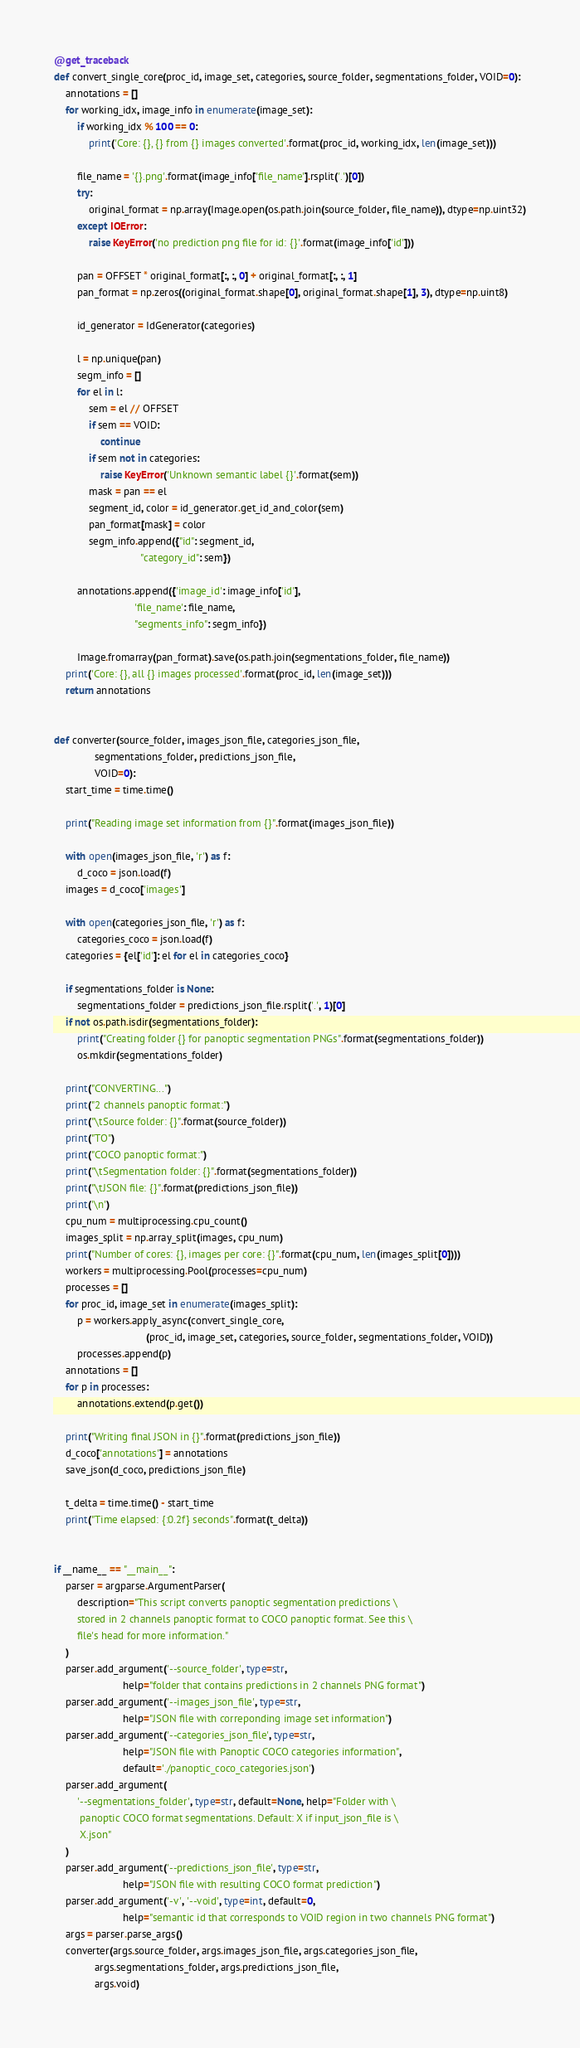<code> <loc_0><loc_0><loc_500><loc_500><_Python_>
@get_traceback
def convert_single_core(proc_id, image_set, categories, source_folder, segmentations_folder, VOID=0):
    annotations = []
    for working_idx, image_info in enumerate(image_set):
        if working_idx % 100 == 0:
            print('Core: {}, {} from {} images converted'.format(proc_id, working_idx, len(image_set)))

        file_name = '{}.png'.format(image_info['file_name'].rsplit('.')[0])
        try:
            original_format = np.array(Image.open(os.path.join(source_folder, file_name)), dtype=np.uint32)
        except IOError:
            raise KeyError('no prediction png file for id: {}'.format(image_info['id']))

        pan = OFFSET * original_format[:, :, 0] + original_format[:, :, 1]
        pan_format = np.zeros((original_format.shape[0], original_format.shape[1], 3), dtype=np.uint8)

        id_generator = IdGenerator(categories)

        l = np.unique(pan)
        segm_info = []
        for el in l:
            sem = el // OFFSET
            if sem == VOID:
                continue
            if sem not in categories:
                raise KeyError('Unknown semantic label {}'.format(sem))
            mask = pan == el
            segment_id, color = id_generator.get_id_and_color(sem)
            pan_format[mask] = color
            segm_info.append({"id": segment_id,
                              "category_id": sem})

        annotations.append({'image_id': image_info['id'],
                            'file_name': file_name,
                            "segments_info": segm_info})

        Image.fromarray(pan_format).save(os.path.join(segmentations_folder, file_name))
    print('Core: {}, all {} images processed'.format(proc_id, len(image_set)))
    return annotations


def converter(source_folder, images_json_file, categories_json_file,
              segmentations_folder, predictions_json_file,
              VOID=0):
    start_time = time.time()

    print("Reading image set information from {}".format(images_json_file))

    with open(images_json_file, 'r') as f:
        d_coco = json.load(f)
    images = d_coco['images']

    with open(categories_json_file, 'r') as f:
        categories_coco = json.load(f)
    categories = {el['id']: el for el in categories_coco}

    if segmentations_folder is None:
        segmentations_folder = predictions_json_file.rsplit('.', 1)[0]
    if not os.path.isdir(segmentations_folder):
        print("Creating folder {} for panoptic segmentation PNGs".format(segmentations_folder))
        os.mkdir(segmentations_folder)

    print("CONVERTING...")
    print("2 channels panoptic format:")
    print("\tSource folder: {}".format(source_folder))
    print("TO")
    print("COCO panoptic format:")
    print("\tSegmentation folder: {}".format(segmentations_folder))
    print("\tJSON file: {}".format(predictions_json_file))
    print('\n')
    cpu_num = multiprocessing.cpu_count()
    images_split = np.array_split(images, cpu_num)
    print("Number of cores: {}, images per core: {}".format(cpu_num, len(images_split[0])))
    workers = multiprocessing.Pool(processes=cpu_num)
    processes = []
    for proc_id, image_set in enumerate(images_split):
        p = workers.apply_async(convert_single_core,
                                (proc_id, image_set, categories, source_folder, segmentations_folder, VOID))
        processes.append(p)
    annotations = []
    for p in processes:
        annotations.extend(p.get())

    print("Writing final JSON in {}".format(predictions_json_file))
    d_coco['annotations'] = annotations
    save_json(d_coco, predictions_json_file)

    t_delta = time.time() - start_time
    print("Time elapsed: {:0.2f} seconds".format(t_delta))


if __name__ == "__main__":
    parser = argparse.ArgumentParser(
        description="This script converts panoptic segmentation predictions \
        stored in 2 channels panoptic format to COCO panoptic format. See this \
        file's head for more information."
    )
    parser.add_argument('--source_folder', type=str,
                        help="folder that contains predictions in 2 channels PNG format")
    parser.add_argument('--images_json_file', type=str,
                        help="JSON file with correponding image set information")
    parser.add_argument('--categories_json_file', type=str,
                        help="JSON file with Panoptic COCO categories information",
                        default='./panoptic_coco_categories.json')
    parser.add_argument(
        '--segmentations_folder', type=str, default=None, help="Folder with \
         panoptic COCO format segmentations. Default: X if input_json_file is \
         X.json"
    )
    parser.add_argument('--predictions_json_file', type=str,
                        help="JSON file with resulting COCO format prediction")
    parser.add_argument('-v', '--void', type=int, default=0,
                        help="semantic id that corresponds to VOID region in two channels PNG format")
    args = parser.parse_args()
    converter(args.source_folder, args.images_json_file, args.categories_json_file,
              args.segmentations_folder, args.predictions_json_file,
              args.void)
</code> 